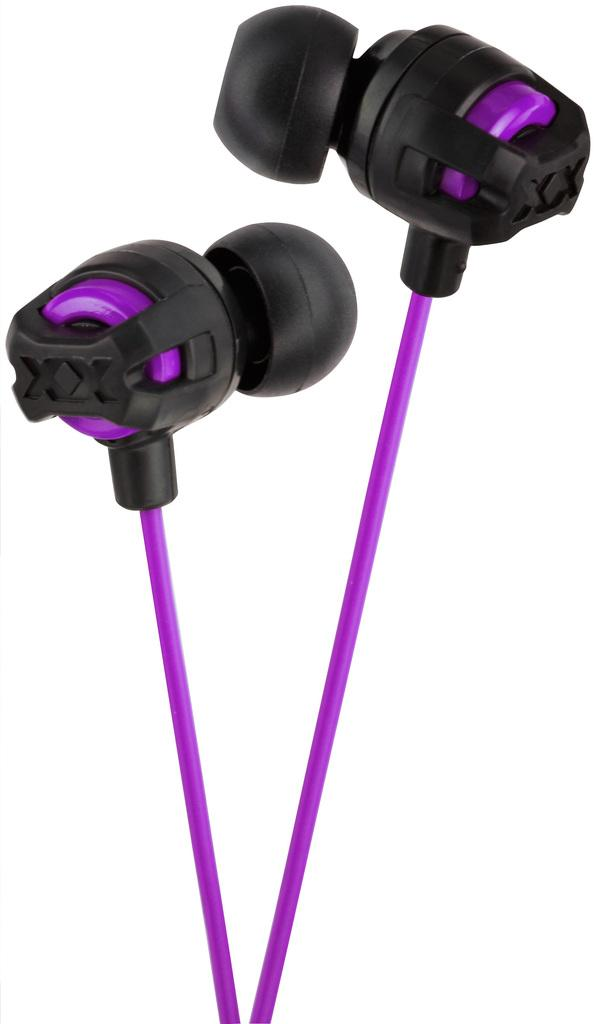What type of audio accessory is present in the image? There are earphones in the image. How are the earphones depicted in the image? The earphones are truncated in the image. What color is the background of the image? The background of the image is white. How many marbles are rolling on the floor in the image? There are no marbles present in the image; it only features earphones. What type of adjustment can be made to the earphones in the image? The image does not show any adjustment options for the earphones, as they are truncated. 